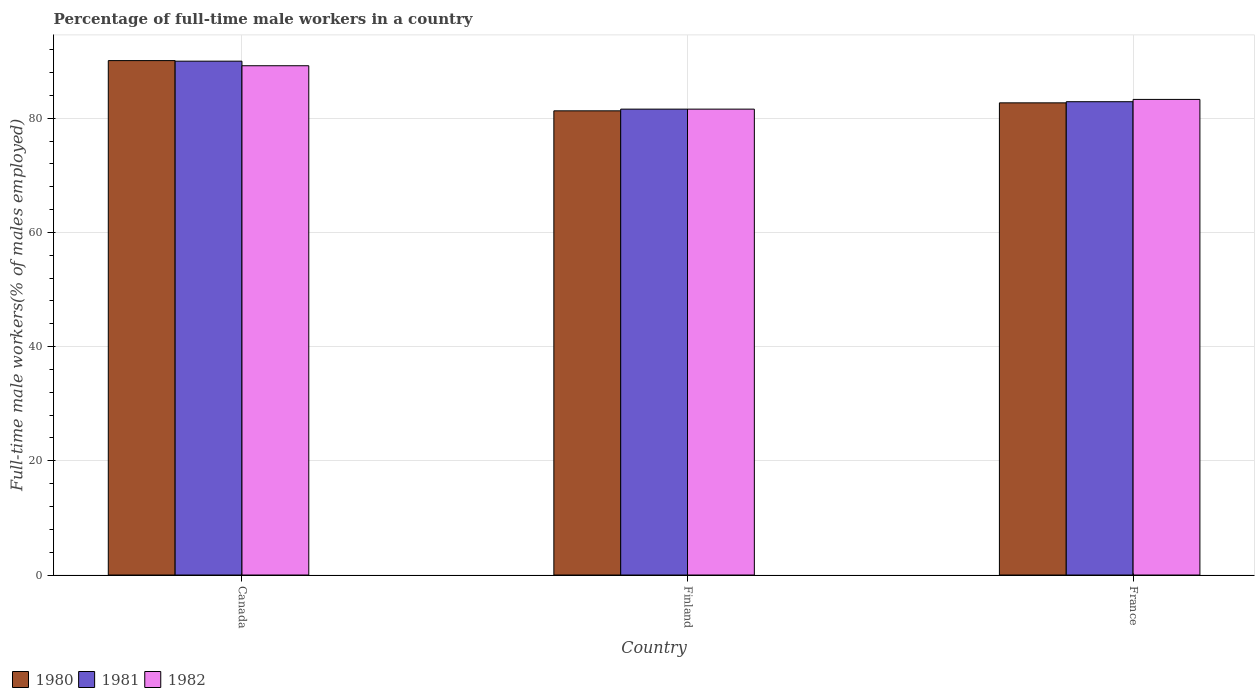How many different coloured bars are there?
Give a very brief answer. 3. How many groups of bars are there?
Your answer should be very brief. 3. Are the number of bars on each tick of the X-axis equal?
Offer a very short reply. Yes. How many bars are there on the 2nd tick from the right?
Keep it short and to the point. 3. What is the label of the 1st group of bars from the left?
Keep it short and to the point. Canada. In how many cases, is the number of bars for a given country not equal to the number of legend labels?
Offer a terse response. 0. Across all countries, what is the minimum percentage of full-time male workers in 1981?
Make the answer very short. 81.6. What is the total percentage of full-time male workers in 1981 in the graph?
Offer a terse response. 254.5. What is the difference between the percentage of full-time male workers in 1981 in Canada and that in Finland?
Offer a very short reply. 8.4. What is the difference between the percentage of full-time male workers in 1980 in Finland and the percentage of full-time male workers in 1981 in France?
Your answer should be very brief. -1.6. What is the average percentage of full-time male workers in 1981 per country?
Keep it short and to the point. 84.83. What is the difference between the percentage of full-time male workers of/in 1982 and percentage of full-time male workers of/in 1980 in Finland?
Your answer should be compact. 0.3. In how many countries, is the percentage of full-time male workers in 1981 greater than 24 %?
Ensure brevity in your answer.  3. What is the ratio of the percentage of full-time male workers in 1980 in Canada to that in France?
Your answer should be compact. 1.09. Is the difference between the percentage of full-time male workers in 1982 in Finland and France greater than the difference between the percentage of full-time male workers in 1980 in Finland and France?
Your answer should be compact. No. What is the difference between the highest and the second highest percentage of full-time male workers in 1980?
Your answer should be very brief. -8.8. What is the difference between the highest and the lowest percentage of full-time male workers in 1981?
Your answer should be compact. 8.4. Is the sum of the percentage of full-time male workers in 1981 in Canada and Finland greater than the maximum percentage of full-time male workers in 1980 across all countries?
Offer a very short reply. Yes. What does the 1st bar from the left in Finland represents?
Keep it short and to the point. 1980. How many bars are there?
Ensure brevity in your answer.  9. Are all the bars in the graph horizontal?
Your response must be concise. No. How many countries are there in the graph?
Ensure brevity in your answer.  3. Are the values on the major ticks of Y-axis written in scientific E-notation?
Make the answer very short. No. Does the graph contain grids?
Provide a succinct answer. Yes. What is the title of the graph?
Provide a succinct answer. Percentage of full-time male workers in a country. Does "1984" appear as one of the legend labels in the graph?
Ensure brevity in your answer.  No. What is the label or title of the X-axis?
Give a very brief answer. Country. What is the label or title of the Y-axis?
Provide a succinct answer. Full-time male workers(% of males employed). What is the Full-time male workers(% of males employed) in 1980 in Canada?
Offer a very short reply. 90.1. What is the Full-time male workers(% of males employed) of 1982 in Canada?
Offer a very short reply. 89.2. What is the Full-time male workers(% of males employed) in 1980 in Finland?
Your answer should be compact. 81.3. What is the Full-time male workers(% of males employed) in 1981 in Finland?
Your answer should be very brief. 81.6. What is the Full-time male workers(% of males employed) in 1982 in Finland?
Your answer should be very brief. 81.6. What is the Full-time male workers(% of males employed) of 1980 in France?
Offer a terse response. 82.7. What is the Full-time male workers(% of males employed) in 1981 in France?
Provide a succinct answer. 82.9. What is the Full-time male workers(% of males employed) in 1982 in France?
Your answer should be compact. 83.3. Across all countries, what is the maximum Full-time male workers(% of males employed) in 1980?
Provide a succinct answer. 90.1. Across all countries, what is the maximum Full-time male workers(% of males employed) in 1982?
Offer a very short reply. 89.2. Across all countries, what is the minimum Full-time male workers(% of males employed) of 1980?
Ensure brevity in your answer.  81.3. Across all countries, what is the minimum Full-time male workers(% of males employed) in 1981?
Your answer should be compact. 81.6. Across all countries, what is the minimum Full-time male workers(% of males employed) in 1982?
Your answer should be very brief. 81.6. What is the total Full-time male workers(% of males employed) of 1980 in the graph?
Make the answer very short. 254.1. What is the total Full-time male workers(% of males employed) of 1981 in the graph?
Your answer should be compact. 254.5. What is the total Full-time male workers(% of males employed) of 1982 in the graph?
Your answer should be very brief. 254.1. What is the difference between the Full-time male workers(% of males employed) of 1980 in Canada and the Full-time male workers(% of males employed) of 1982 in Finland?
Make the answer very short. 8.5. What is the difference between the Full-time male workers(% of males employed) of 1981 in Canada and the Full-time male workers(% of males employed) of 1982 in Finland?
Provide a short and direct response. 8.4. What is the difference between the Full-time male workers(% of males employed) in 1980 in Canada and the Full-time male workers(% of males employed) in 1982 in France?
Provide a succinct answer. 6.8. What is the difference between the Full-time male workers(% of males employed) in 1981 in Canada and the Full-time male workers(% of males employed) in 1982 in France?
Your response must be concise. 6.7. What is the difference between the Full-time male workers(% of males employed) of 1980 in Finland and the Full-time male workers(% of males employed) of 1981 in France?
Ensure brevity in your answer.  -1.6. What is the difference between the Full-time male workers(% of males employed) in 1980 in Finland and the Full-time male workers(% of males employed) in 1982 in France?
Your answer should be very brief. -2. What is the average Full-time male workers(% of males employed) in 1980 per country?
Make the answer very short. 84.7. What is the average Full-time male workers(% of males employed) in 1981 per country?
Give a very brief answer. 84.83. What is the average Full-time male workers(% of males employed) in 1982 per country?
Provide a succinct answer. 84.7. What is the difference between the Full-time male workers(% of males employed) of 1980 and Full-time male workers(% of males employed) of 1981 in Canada?
Your answer should be very brief. 0.1. What is the difference between the Full-time male workers(% of males employed) of 1981 and Full-time male workers(% of males employed) of 1982 in Canada?
Make the answer very short. 0.8. What is the difference between the Full-time male workers(% of males employed) in 1980 and Full-time male workers(% of males employed) in 1981 in Finland?
Offer a terse response. -0.3. What is the difference between the Full-time male workers(% of males employed) of 1981 and Full-time male workers(% of males employed) of 1982 in Finland?
Give a very brief answer. 0. What is the difference between the Full-time male workers(% of males employed) in 1980 and Full-time male workers(% of males employed) in 1981 in France?
Your response must be concise. -0.2. What is the ratio of the Full-time male workers(% of males employed) of 1980 in Canada to that in Finland?
Your answer should be compact. 1.11. What is the ratio of the Full-time male workers(% of males employed) of 1981 in Canada to that in Finland?
Offer a very short reply. 1.1. What is the ratio of the Full-time male workers(% of males employed) of 1982 in Canada to that in Finland?
Your answer should be compact. 1.09. What is the ratio of the Full-time male workers(% of males employed) of 1980 in Canada to that in France?
Offer a terse response. 1.09. What is the ratio of the Full-time male workers(% of males employed) of 1981 in Canada to that in France?
Your response must be concise. 1.09. What is the ratio of the Full-time male workers(% of males employed) in 1982 in Canada to that in France?
Keep it short and to the point. 1.07. What is the ratio of the Full-time male workers(% of males employed) in 1980 in Finland to that in France?
Provide a succinct answer. 0.98. What is the ratio of the Full-time male workers(% of males employed) of 1981 in Finland to that in France?
Give a very brief answer. 0.98. What is the ratio of the Full-time male workers(% of males employed) in 1982 in Finland to that in France?
Offer a terse response. 0.98. What is the difference between the highest and the second highest Full-time male workers(% of males employed) in 1980?
Keep it short and to the point. 7.4. What is the difference between the highest and the second highest Full-time male workers(% of males employed) in 1981?
Offer a terse response. 7.1. What is the difference between the highest and the second highest Full-time male workers(% of males employed) of 1982?
Give a very brief answer. 5.9. What is the difference between the highest and the lowest Full-time male workers(% of males employed) in 1980?
Your answer should be compact. 8.8. What is the difference between the highest and the lowest Full-time male workers(% of males employed) of 1981?
Offer a very short reply. 8.4. 